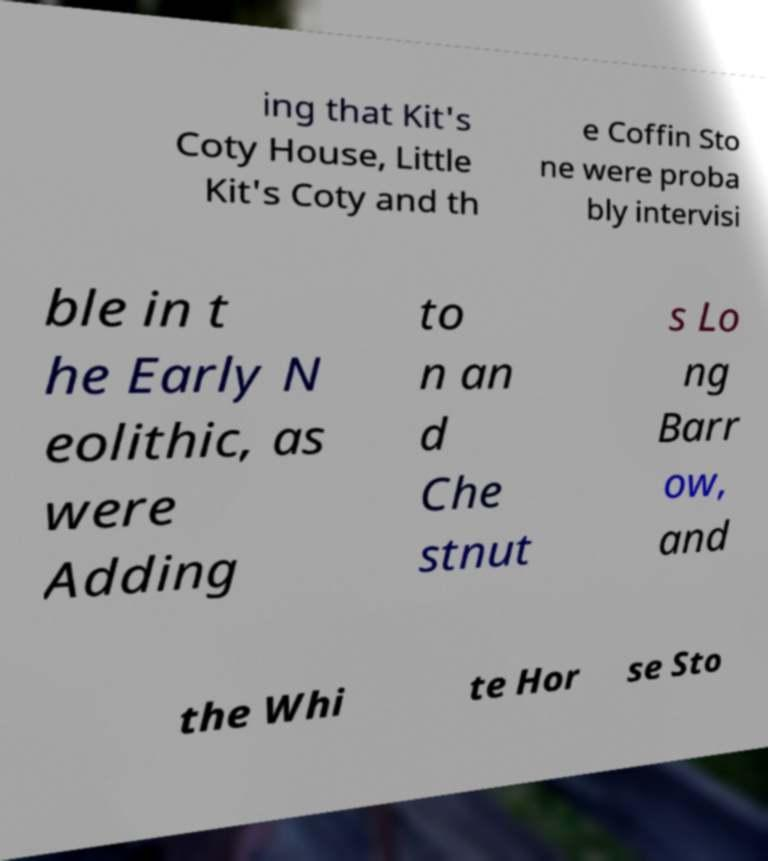I need the written content from this picture converted into text. Can you do that? ing that Kit's Coty House, Little Kit's Coty and th e Coffin Sto ne were proba bly intervisi ble in t he Early N eolithic, as were Adding to n an d Che stnut s Lo ng Barr ow, and the Whi te Hor se Sto 